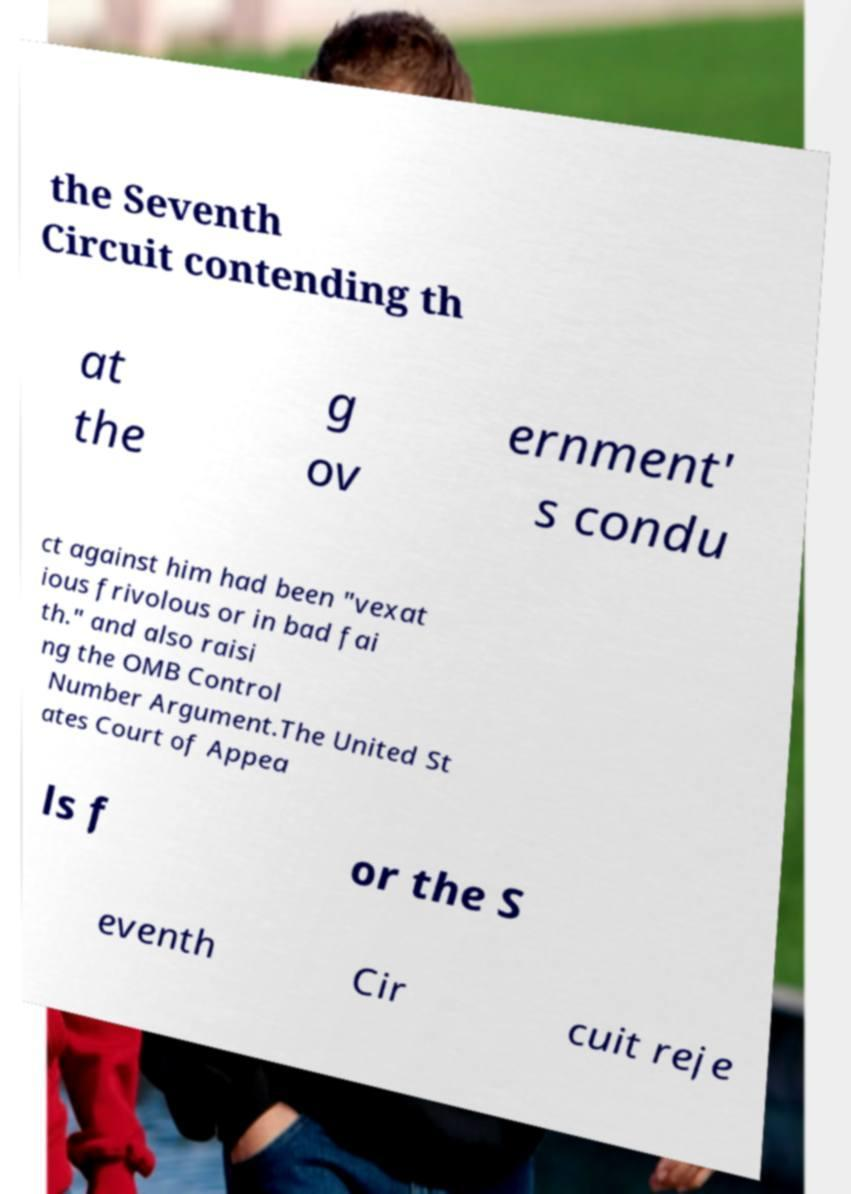Could you extract and type out the text from this image? the Seventh Circuit contending th at the g ov ernment' s condu ct against him had been "vexat ious frivolous or in bad fai th." and also raisi ng the OMB Control Number Argument.The United St ates Court of Appea ls f or the S eventh Cir cuit reje 